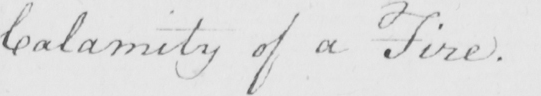What is written in this line of handwriting? Calamity of a Fire . 